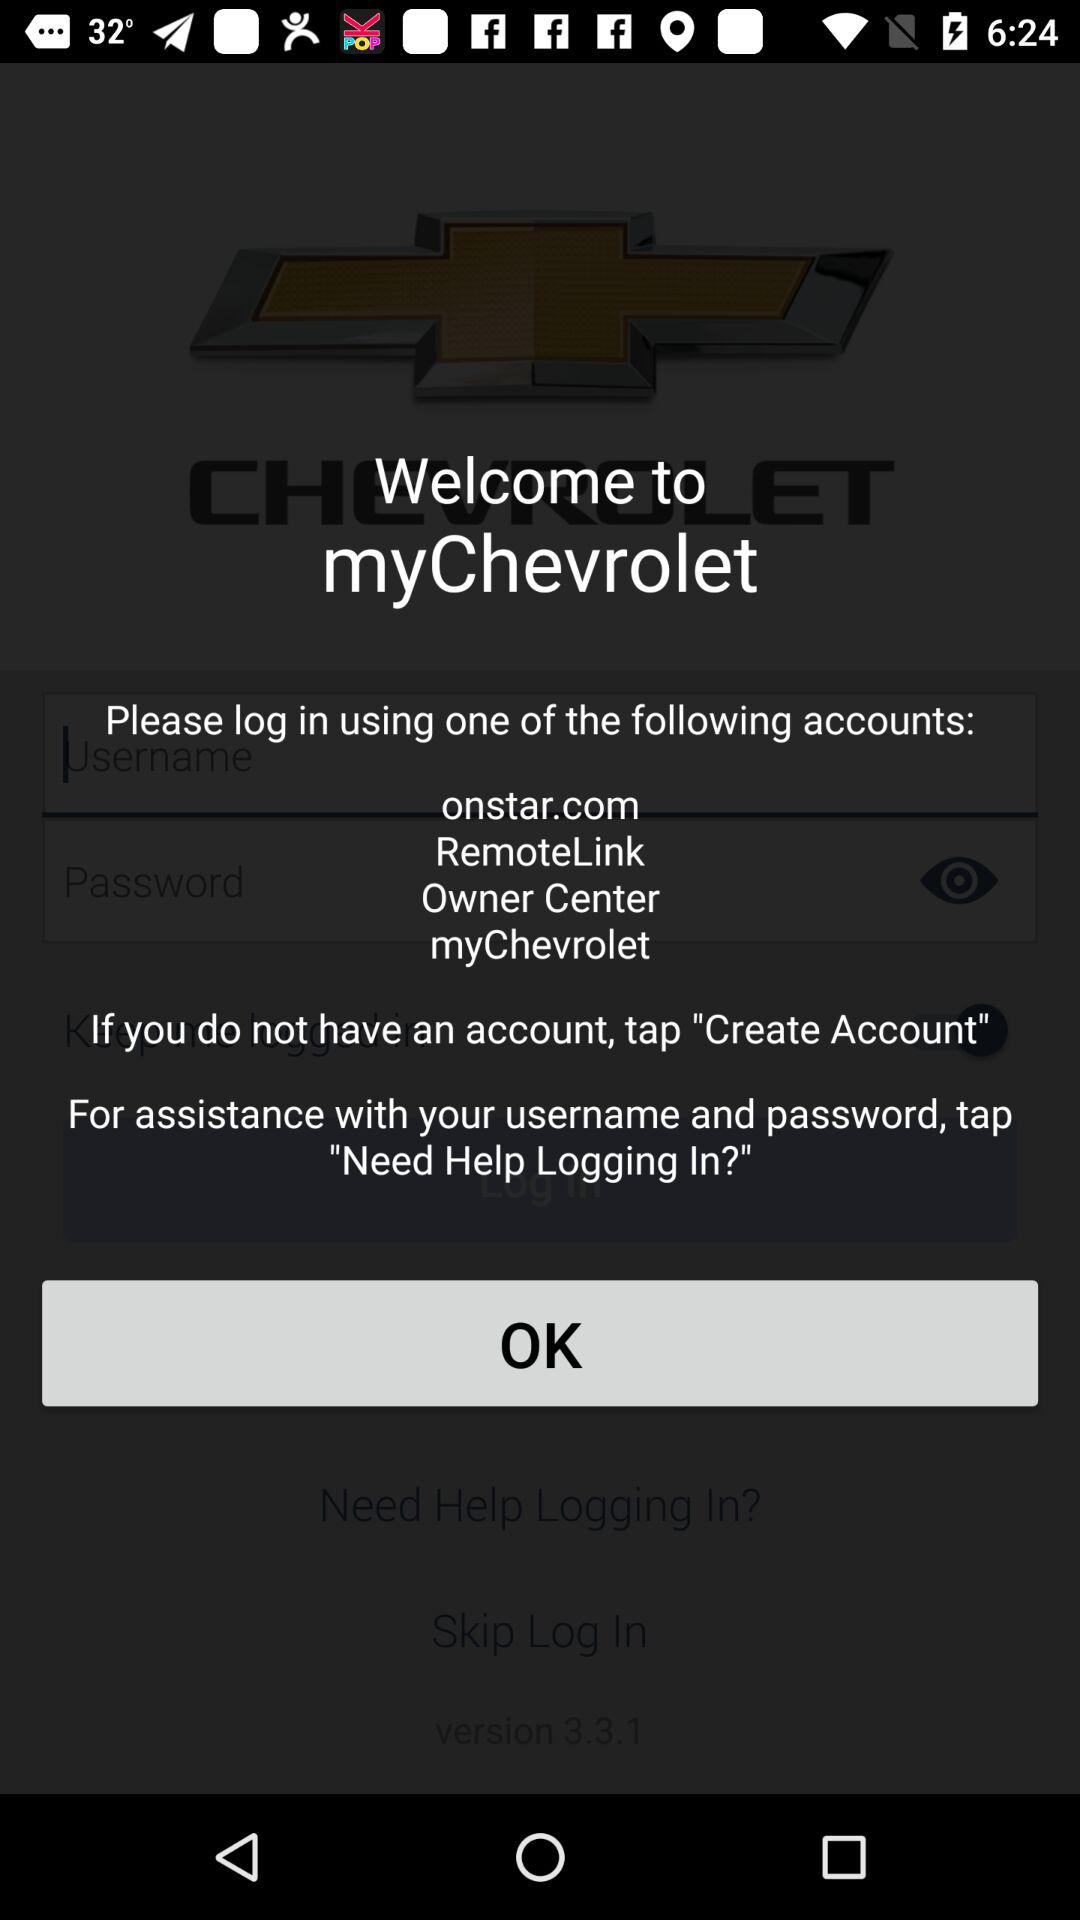Through which accounts can we log in? You can log in through "onstar.com", "RemoteLink", "Owner Center" and "myChevrolet" accounts. 